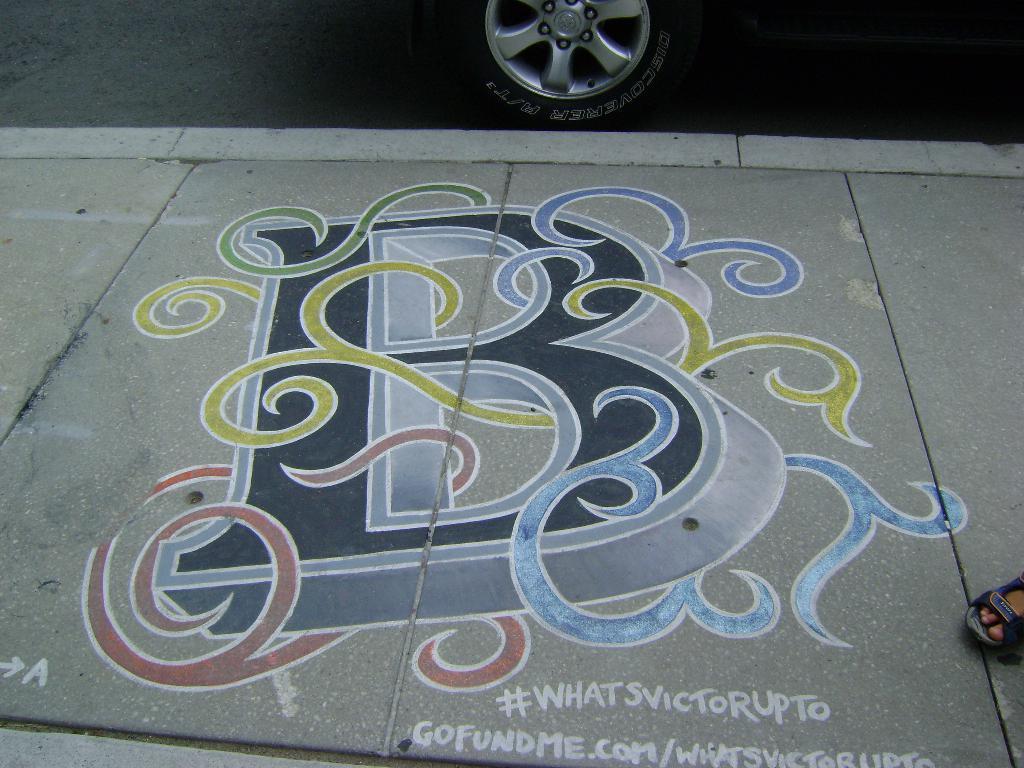In one or two sentences, can you explain what this image depicts? This is the painting, which is drawn on the footpath. This is the wheel. At the very right corner of the image, I can see a person´a foot with a footwear. 